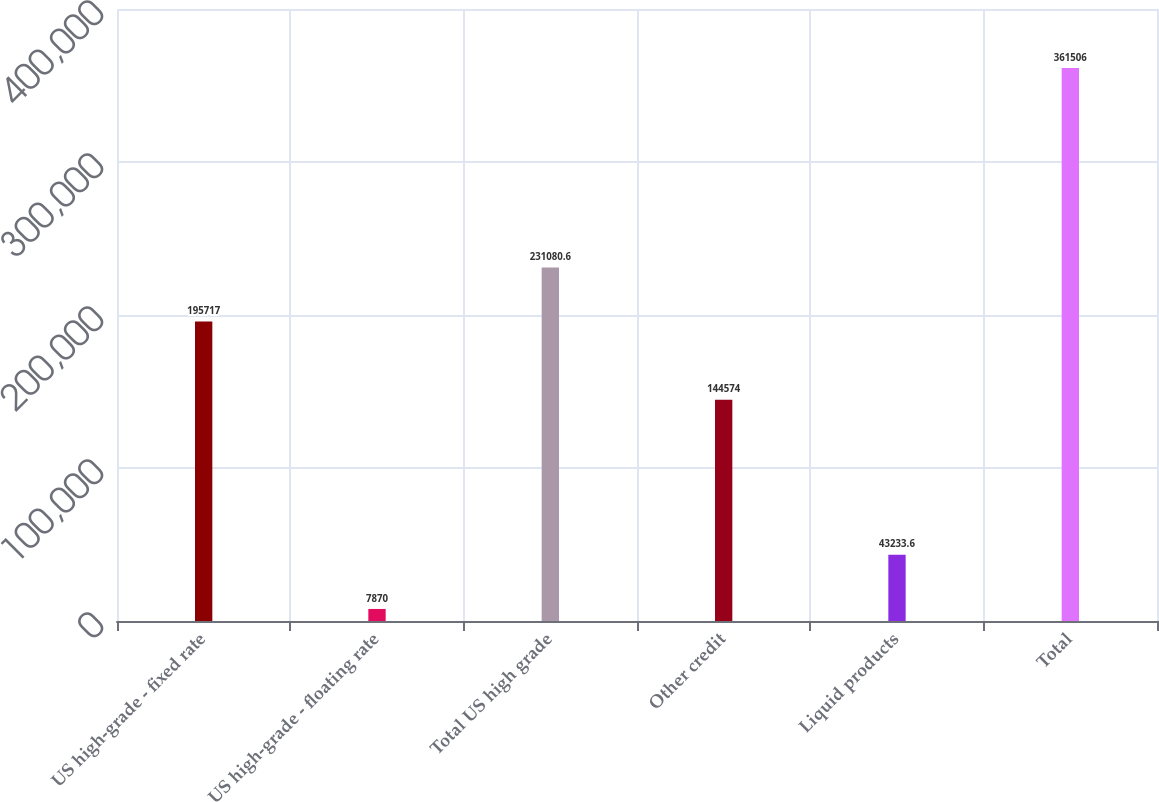<chart> <loc_0><loc_0><loc_500><loc_500><bar_chart><fcel>US high-grade - fixed rate<fcel>US high-grade - floating rate<fcel>Total US high grade<fcel>Other credit<fcel>Liquid products<fcel>Total<nl><fcel>195717<fcel>7870<fcel>231081<fcel>144574<fcel>43233.6<fcel>361506<nl></chart> 